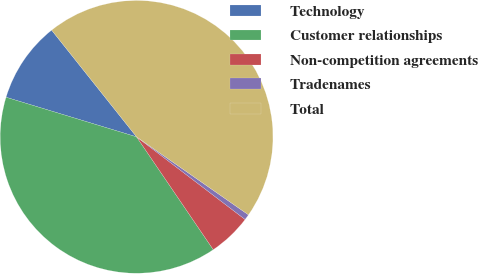Convert chart. <chart><loc_0><loc_0><loc_500><loc_500><pie_chart><fcel>Technology<fcel>Customer relationships<fcel>Non-competition agreements<fcel>Tradenames<fcel>Total<nl><fcel>9.61%<fcel>39.19%<fcel>5.14%<fcel>0.67%<fcel>45.38%<nl></chart> 